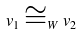<formula> <loc_0><loc_0><loc_500><loc_500>v _ { 1 } \cong _ { W } v _ { 2 }</formula> 